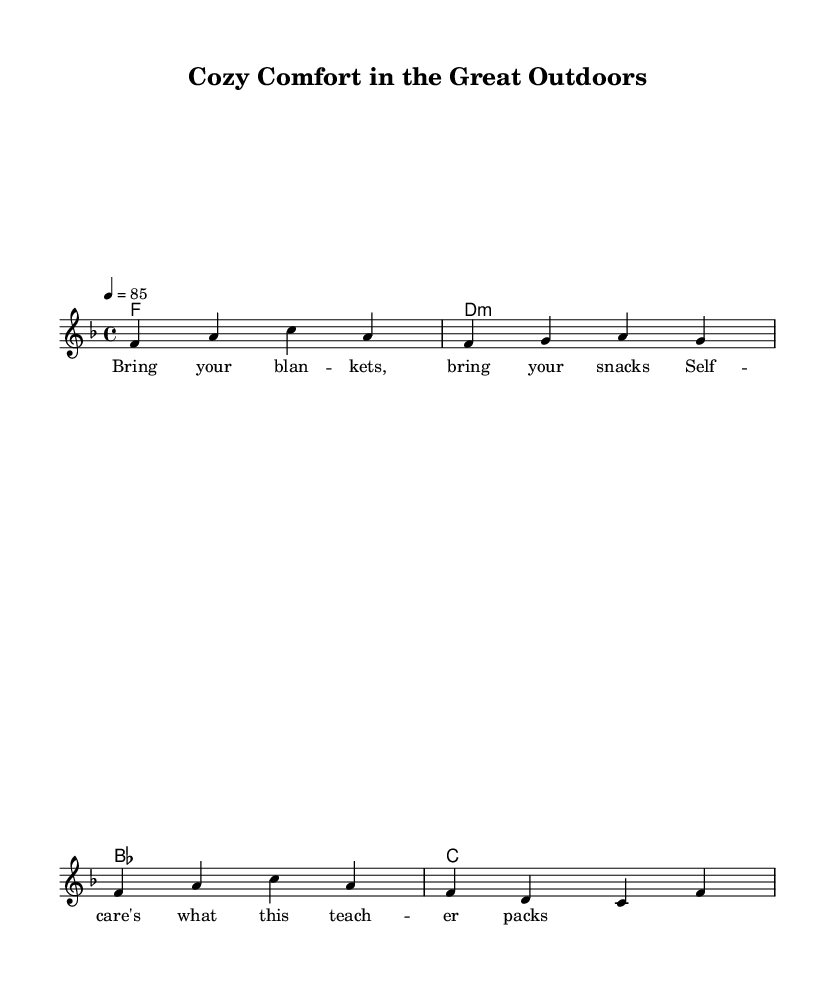What is the key signature of this music? The key signature is indicated at the beginning of the score. Here, it shows one flat, which corresponds to the key of F major.
Answer: F major What is the time signature of the piece? The time signature is displayed at the beginning of the score and indicates the number of beats per measure. In this case, it is 4/4, meaning there are four beats in each measure.
Answer: 4/4 What is the tempo marking for this music? The tempo marking appears in the score indicating the speed of the music. In this case, it is marked as 4 = 85, which means there are 85 beats per minute.
Answer: 85 How many measures are in the melody section? By counting the individual segments separated by vertical lines, you can see there are 4 measures in the melody section of the score.
Answer: 4 What is the first lyric of the verse? The lyrics are listed beneath the melody notes, and the first lyric begins with "Bring your blankets," as seen in the first line of the verse.
Answer: Bring your blankets Which chord is used in the first measure? The chord shown at the beginning of the score is identified in the chord names section. The first chord is an F major chord.
Answer: F What theme does the rap focus on, as reflected in the lyrics? By analyzing the lyrics, it is evident that the theme centers around self-care and the comfort associated with bringing blankets and snacks outdoors, as expressed throughout the verse.
Answer: Self-care 